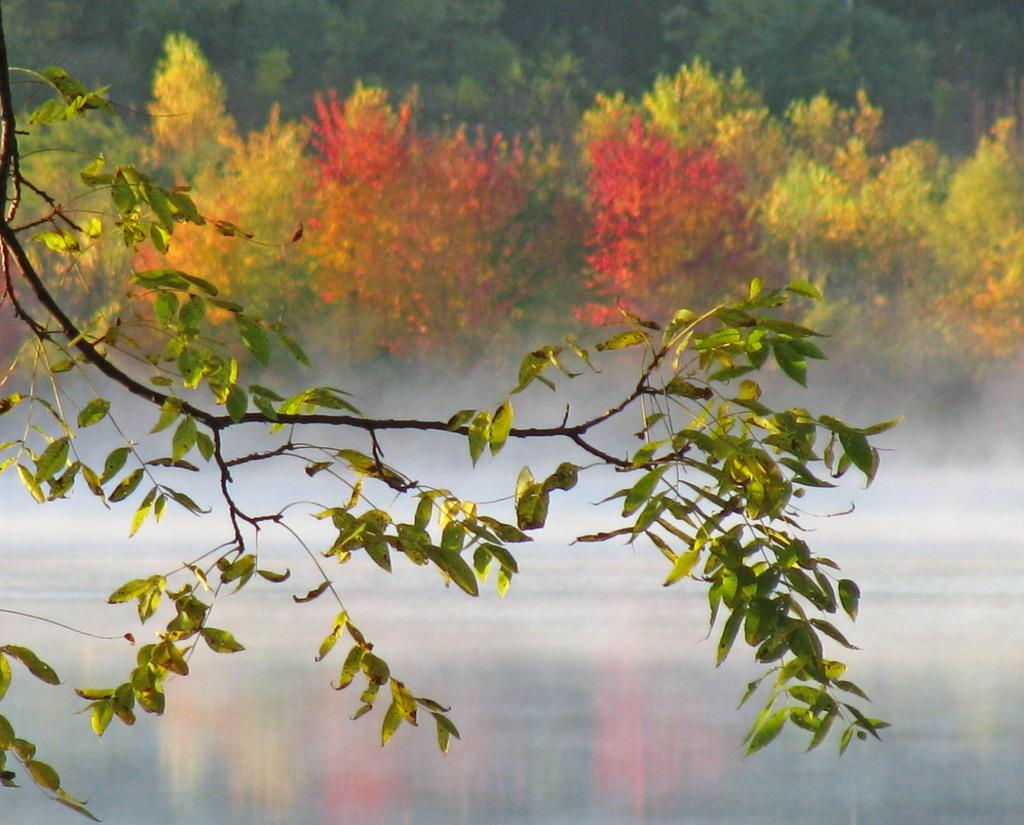What can be seen in the background of the image? There are trees in the background of the image. What is visible in the image besides the trees? There is water visible in the image. Can you describe a specific part of a tree in the image? There is a tree branch with leaves in the image. What type of bottle is floating in the water in the image? There is no bottle present in the image; it only features trees and water. Can you tell me how many eggs are visible on the tree branch with leaves? There are no eggs present on the tree branch with leaves in the image. 